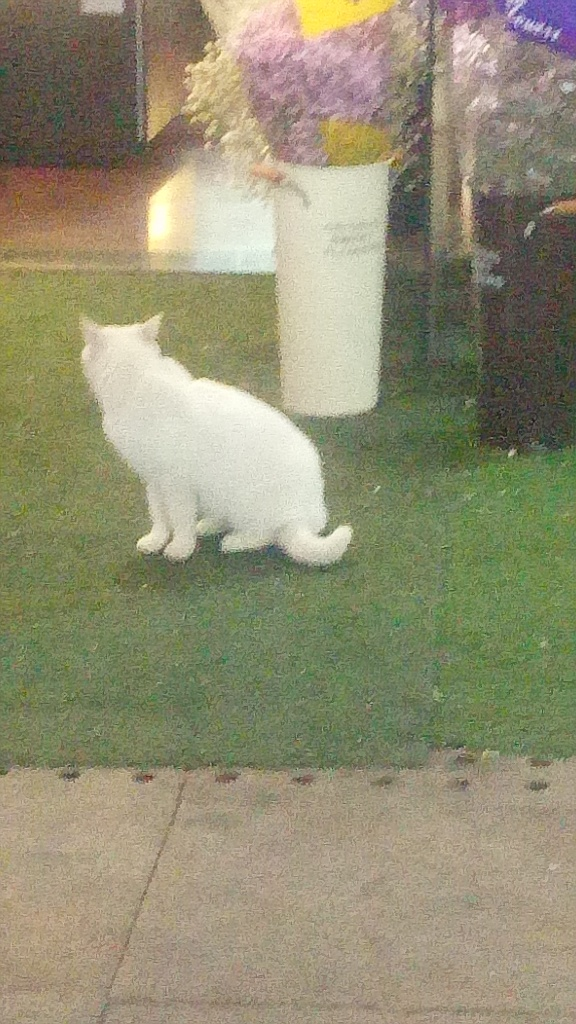What time of day does this image likely represent, and why? The image appears to capture a moment during the evening or night, as suggested by the artificial lighting and the shadows cast. The light source above illuminates the scene in a way that's typical for outdoor spaces after sunset. How does the lighting affect the visual quality of the photo? The lighting in the photo creates a somewhat grainy and blurred effect, which reduces the level of detail that we can perceive in the cat and its surroundings. It also casts a warm glow that contributes to the mood but impacts the sharpness and color accuracy of the image. 